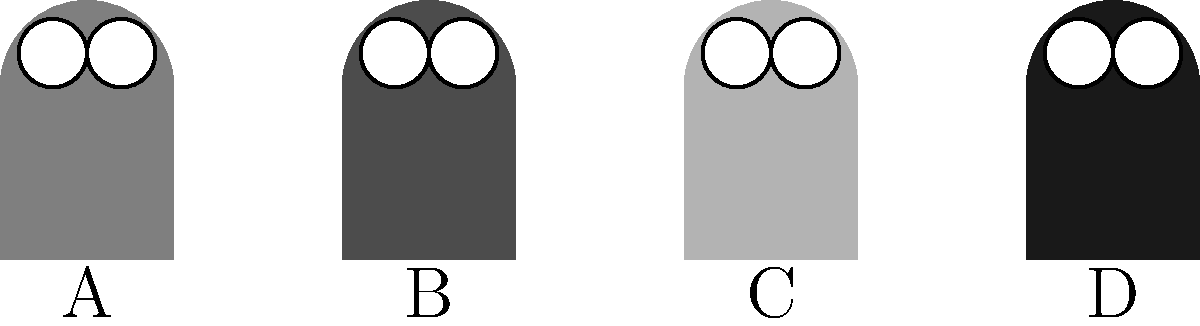In Ben Bova's "Grand Tour" series, various alien life forms are encountered. Based on the silhouettes shown above, which one most likely represents the Wassons, a species known for their adaptability to extreme environments and described as having a compact, sturdy build? To answer this question, we need to analyze the characteristics of the Wassons as described in Ben Bova's works and compare them to the silhouettes provided:

1. The Wassons are known for their adaptability to extreme environments.
2. They are described as having a compact, sturdy build.

Now, let's examine each silhouette:

A. This alien has a medium-gray tone and a relatively balanced shape.
B. This alien has a darker gray tone and appears to have a more compact, sturdy build.
C. This alien has a lighter gray tone and a taller, less compact shape.
D. This alien has the darkest gray tone and appears to be the most slender of the four.

Given that the Wassons are described as having a compact, sturdy build, silhouette B best matches this description. Its darker tone could also suggest an ability to withstand harsh environments, which aligns with the Wassons' adaptability.

The other silhouettes are less likely candidates:
- A is not as compact as B
- C is too tall and less sturdy-looking
- D is too slender and doesn't appear compact or sturdy

Therefore, silhouette B is the most likely representation of the Wassons.
Answer: B 